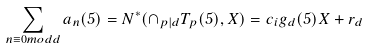<formula> <loc_0><loc_0><loc_500><loc_500>\sum _ { n \equiv 0 m o d d } a _ { n } ( 5 ) = N ^ { * } ( \cap _ { p | d } T _ { p } ( 5 ) , X ) = c _ { i } g _ { d } ( 5 ) X + r _ { d }</formula> 